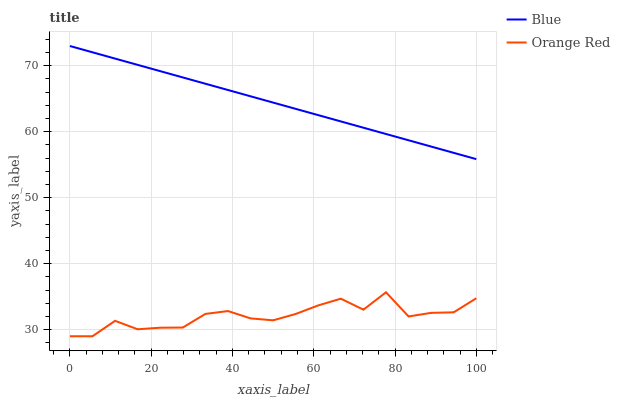Does Orange Red have the minimum area under the curve?
Answer yes or no. Yes. Does Blue have the maximum area under the curve?
Answer yes or no. Yes. Does Orange Red have the maximum area under the curve?
Answer yes or no. No. Is Blue the smoothest?
Answer yes or no. Yes. Is Orange Red the roughest?
Answer yes or no. Yes. Is Orange Red the smoothest?
Answer yes or no. No. Does Orange Red have the lowest value?
Answer yes or no. Yes. Does Blue have the highest value?
Answer yes or no. Yes. Does Orange Red have the highest value?
Answer yes or no. No. Is Orange Red less than Blue?
Answer yes or no. Yes. Is Blue greater than Orange Red?
Answer yes or no. Yes. Does Orange Red intersect Blue?
Answer yes or no. No. 